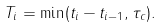<formula> <loc_0><loc_0><loc_500><loc_500>T _ { i } = \min ( t _ { i } - t _ { i - 1 } , \tau _ { c } ) .</formula> 